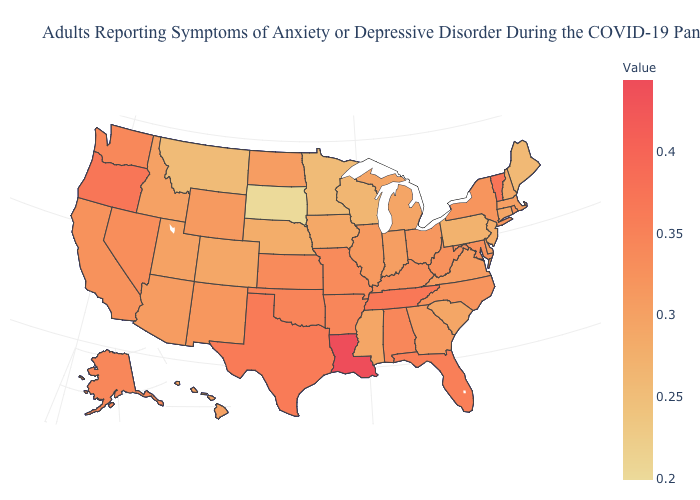Does the map have missing data?
Give a very brief answer. No. Which states have the lowest value in the South?
Be succinct. Mississippi, South Carolina. Is the legend a continuous bar?
Short answer required. Yes. Which states have the highest value in the USA?
Write a very short answer. Louisiana. Does South Carolina have the lowest value in the South?
Give a very brief answer. Yes. Does Montana have the lowest value in the West?
Answer briefly. Yes. Does Florida have the lowest value in the South?
Concise answer only. No. 